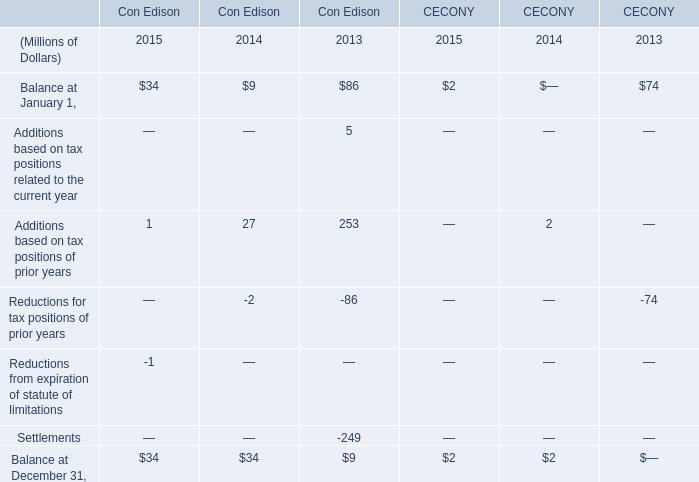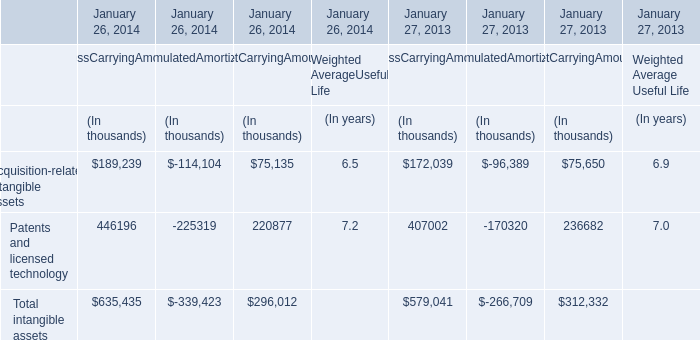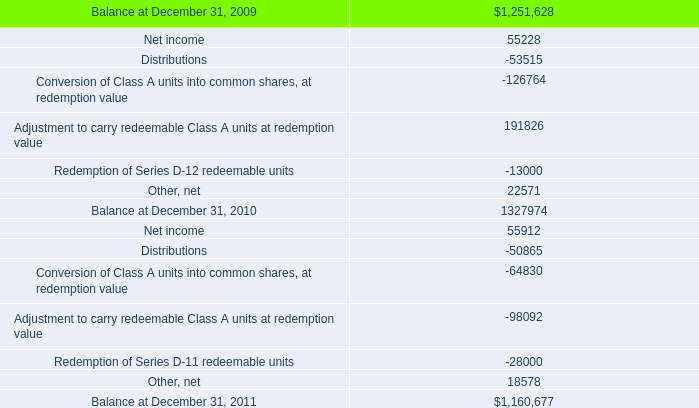What's the 2015 growth rate of Balance at January 1 of Con Edison? 
Computations: ((34 - 9) / 9)
Answer: 2.77778. 